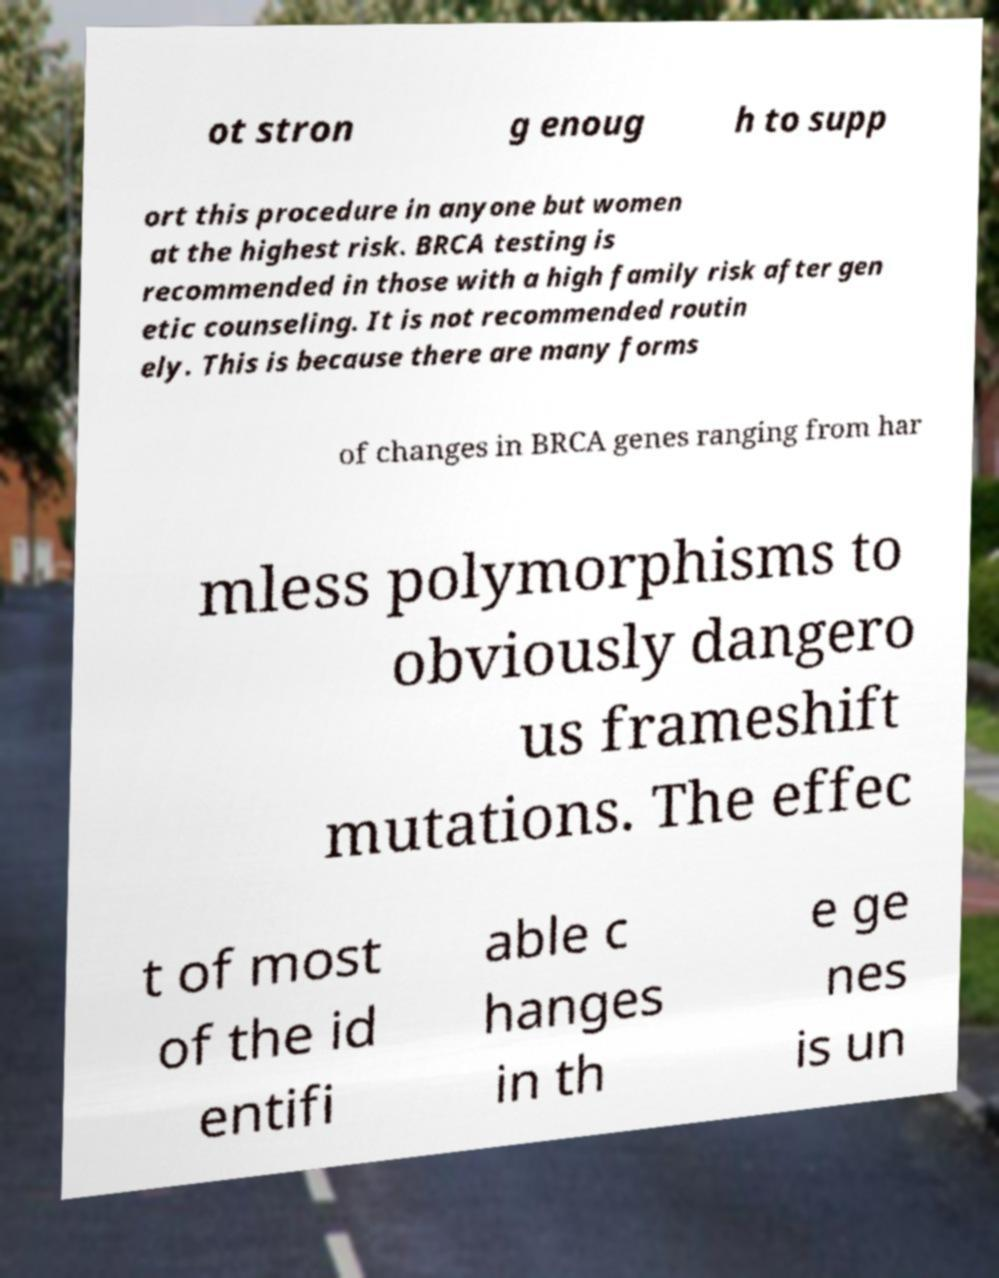I need the written content from this picture converted into text. Can you do that? ot stron g enoug h to supp ort this procedure in anyone but women at the highest risk. BRCA testing is recommended in those with a high family risk after gen etic counseling. It is not recommended routin ely. This is because there are many forms of changes in BRCA genes ranging from har mless polymorphisms to obviously dangero us frameshift mutations. The effec t of most of the id entifi able c hanges in th e ge nes is un 